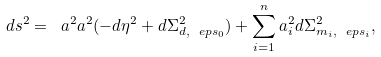<formula> <loc_0><loc_0><loc_500><loc_500>d s ^ { 2 } = \ a ^ { 2 } a ^ { 2 } ( - d \eta ^ { 2 } + d \Sigma _ { d , \ e p s _ { 0 } } ^ { 2 } ) + \sum _ { i = 1 } ^ { n } a _ { i } ^ { 2 } d \Sigma _ { m _ { i } , \ e p s _ { i } } ^ { 2 } ,</formula> 